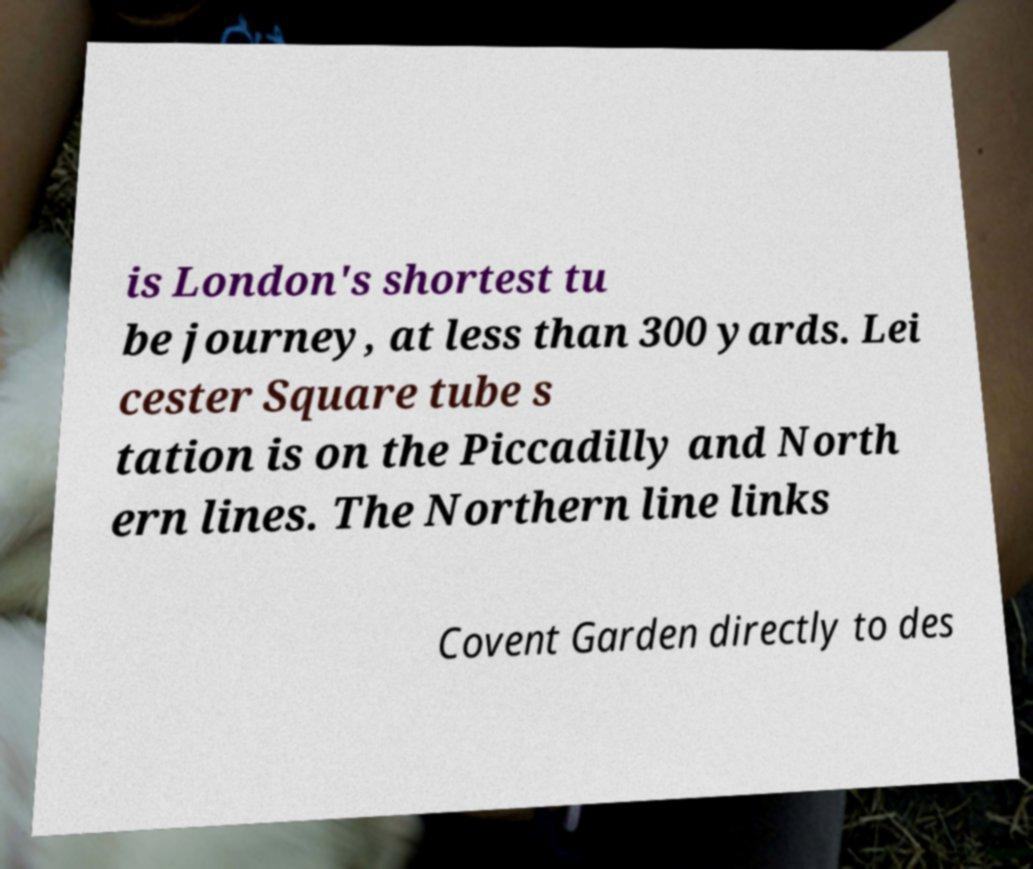Can you read and provide the text displayed in the image?This photo seems to have some interesting text. Can you extract and type it out for me? is London's shortest tu be journey, at less than 300 yards. Lei cester Square tube s tation is on the Piccadilly and North ern lines. The Northern line links Covent Garden directly to des 